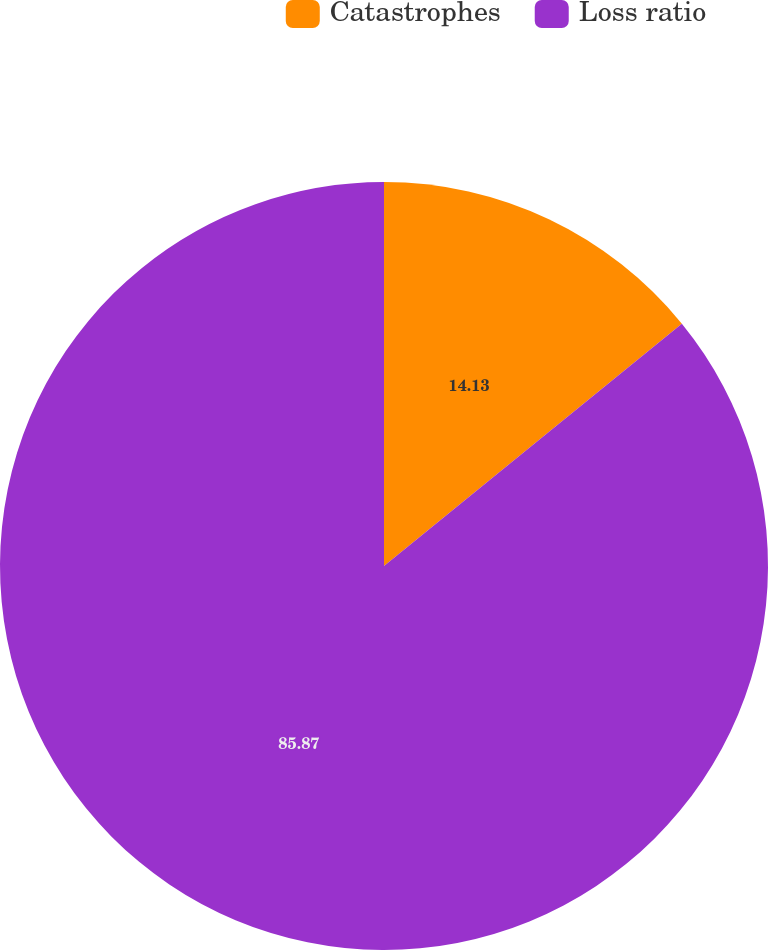Convert chart to OTSL. <chart><loc_0><loc_0><loc_500><loc_500><pie_chart><fcel>Catastrophes<fcel>Loss ratio<nl><fcel>14.13%<fcel>85.87%<nl></chart> 